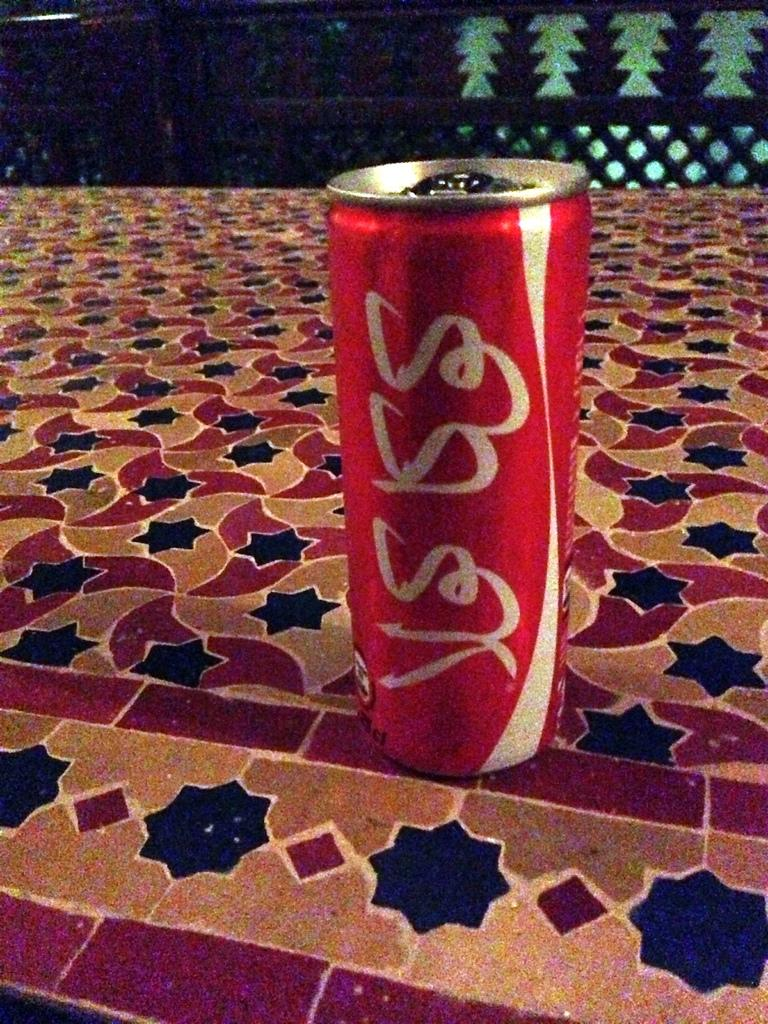<image>
Write a terse but informative summary of the picture. A can of of Coca Cola from a foreign country has 2% cl in it 